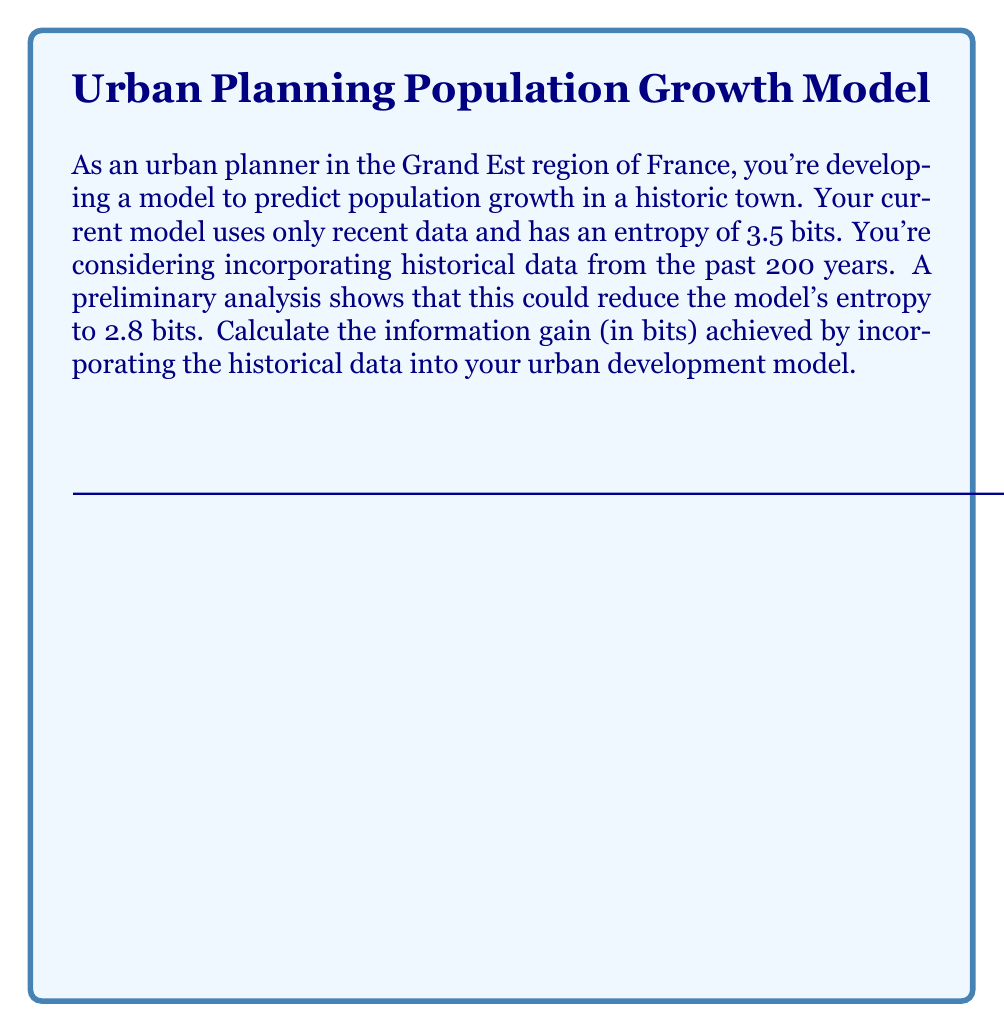What is the answer to this math problem? To solve this problem, we need to understand the concept of information gain in the context of entropy reduction. Information gain is the reduction in entropy achieved by incorporating new information into a model.

Let's approach this step-by-step:

1) The entropy of the current model: $H_1 = 3.5$ bits

2) The entropy of the model with historical data: $H_2 = 2.8$ bits

3) The information gain (IG) is the difference between these two entropies:

   $IG = H_1 - H_2$

4) Substituting the values:

   $IG = 3.5 - 2.8$

5) Calculating:

   $IG = 0.7$ bits

This means that by incorporating the historical data, we gain 0.7 bits of information. In the context of urban planning, this represents a significant improvement in the model's predictive power, allowing for more accurate population growth forecasts and better-informed urban development decisions in the historic town.
Answer: 0.7 bits 